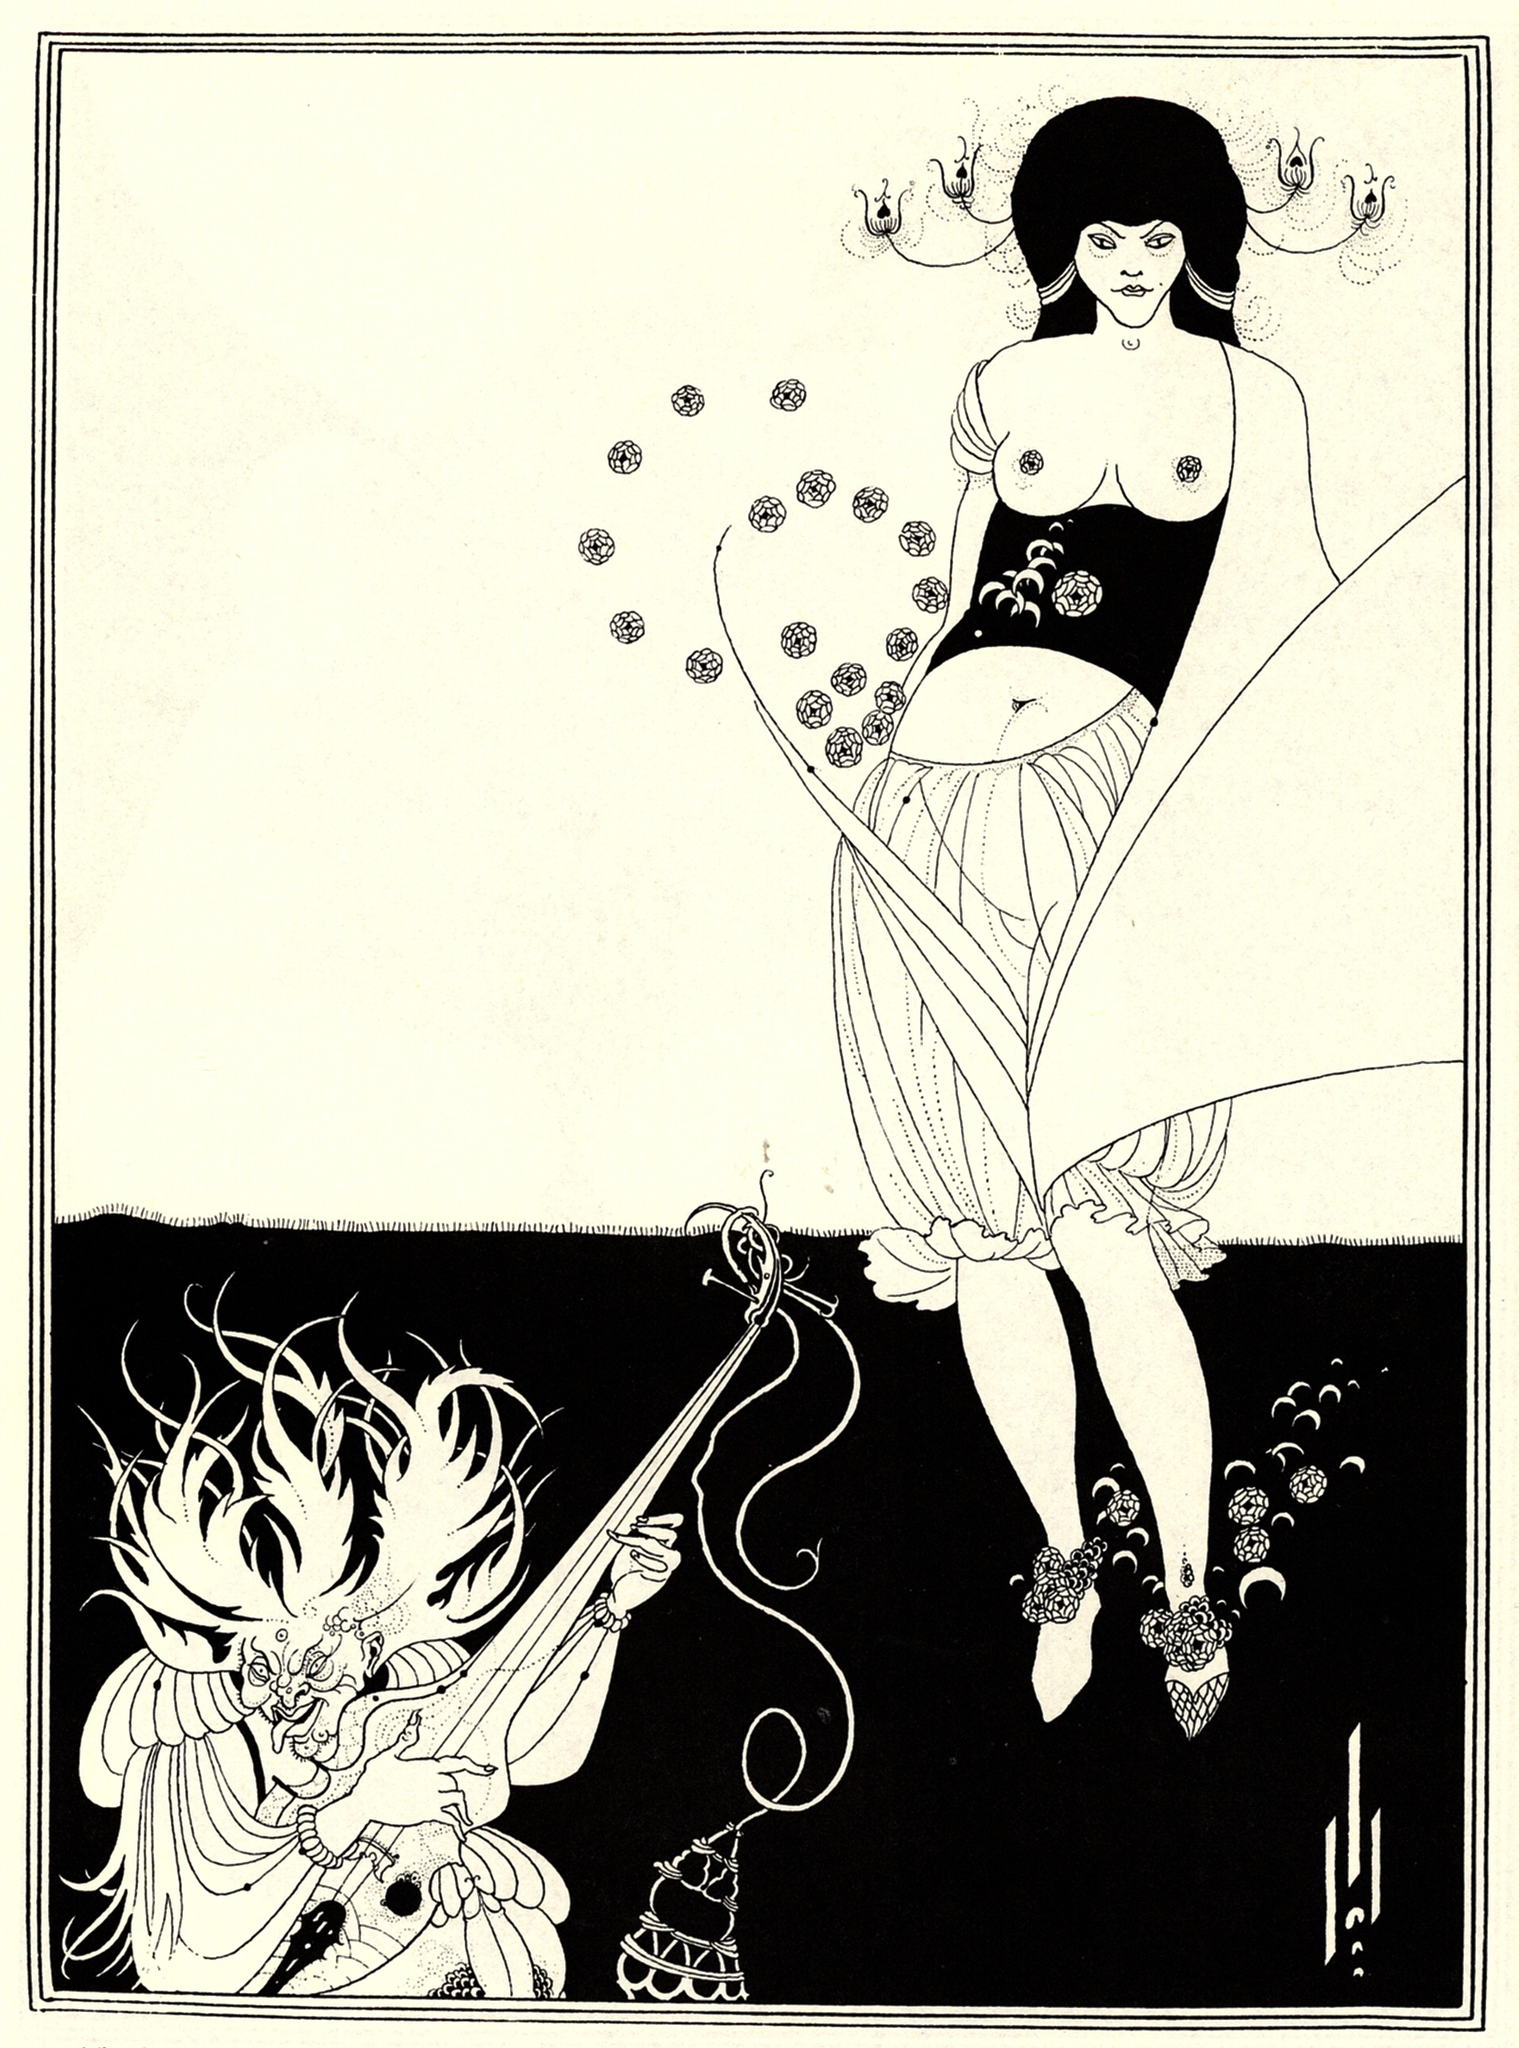Describe the emotions being conveyed by the characters in the scene. In the scene, the woman exudes a calm and composed demeanor, her head turned to the side as if contemplating something profound. Her posture and the floral motifs on her dress suggest a sense of tranquility and elegance. On the other hand, the dragon displays a more intense and dramatic emotion. With its wild hair flowing and arms outstretched holding a censer and a sword, the dragon seems to be in a state of heightened alertness or aggression. The juxtaposition of these two emotional states—serenity and intensity—creates a dynamic tension within the artwork, drawing the viewer into the narrative being portrayed. 